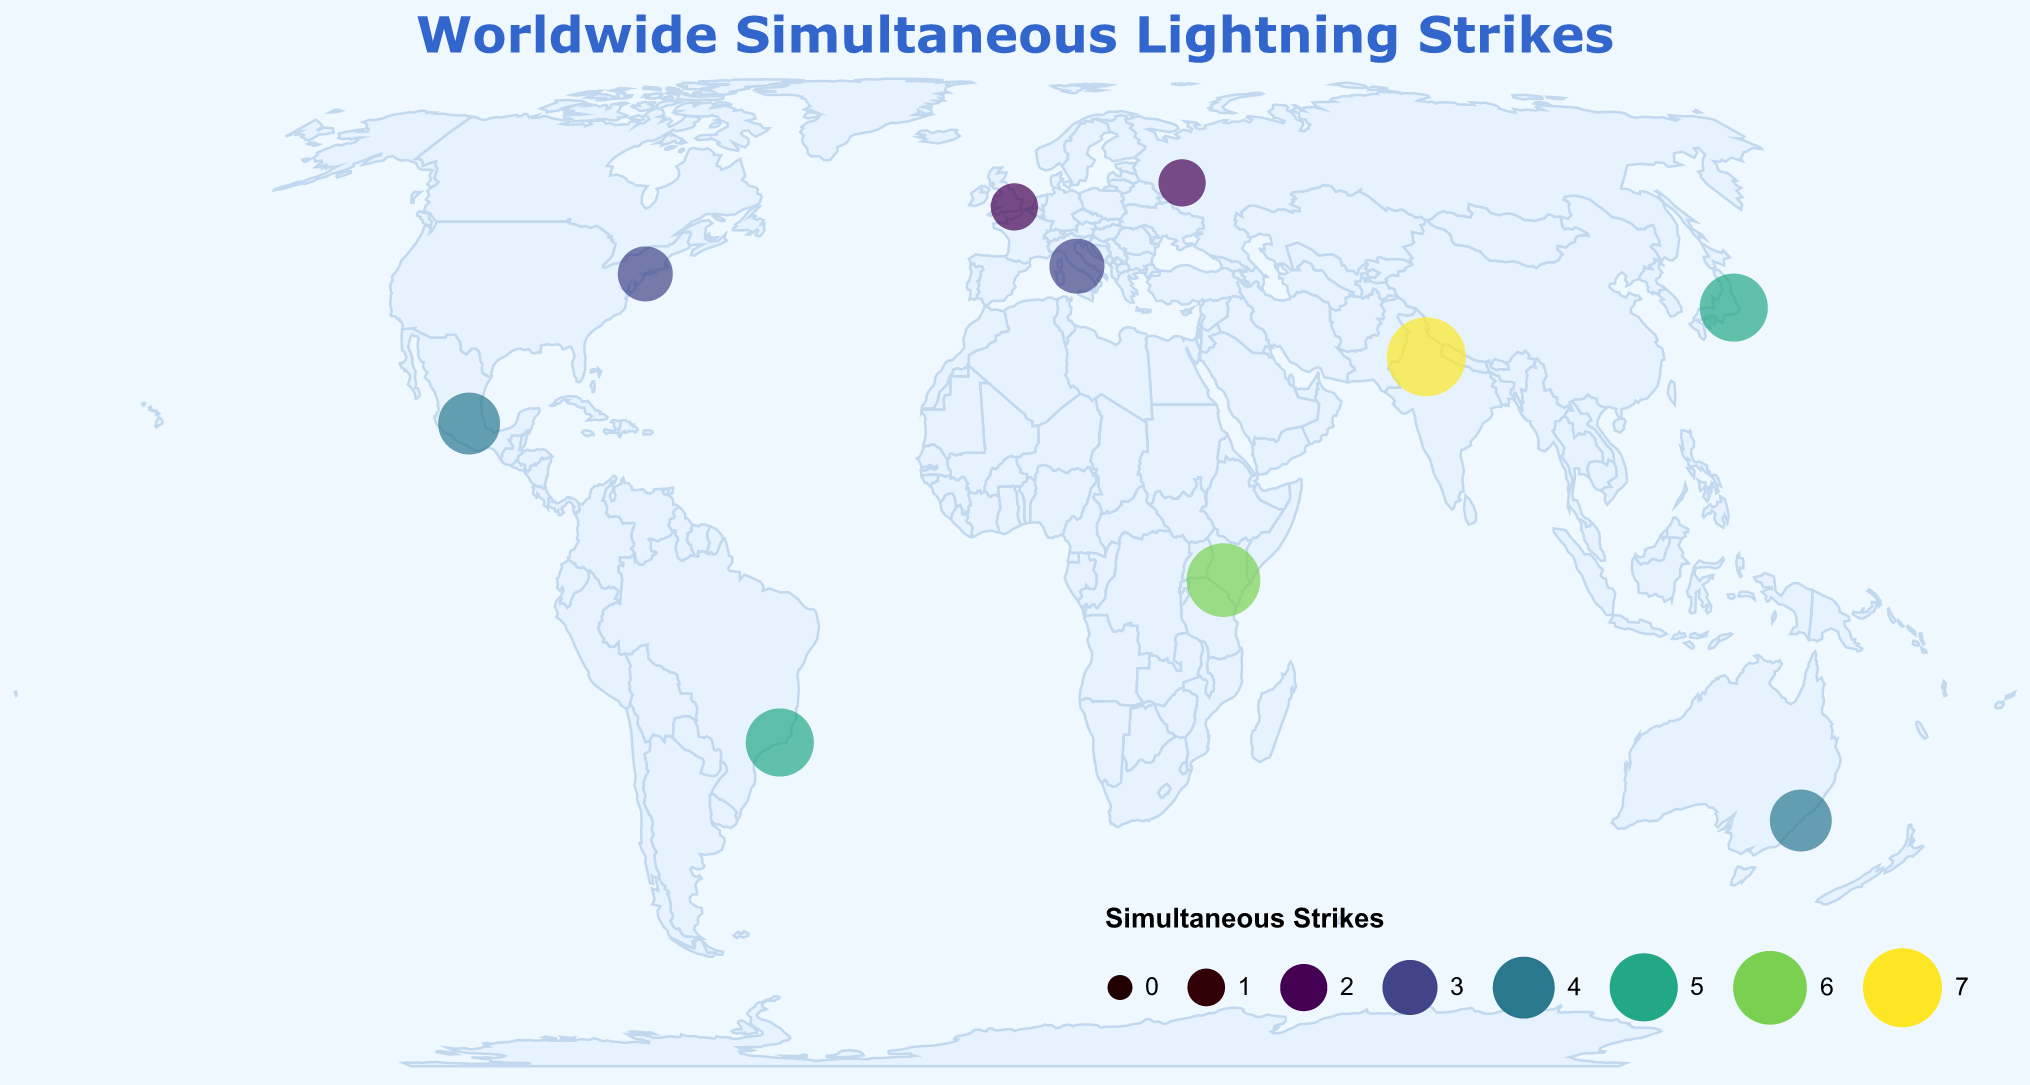Which city experienced the highest number of simultaneous lightning strikes? Find the city with the highest value in the 'Simultaneous Strikes' field, which is New Delhi with 7 strikes.
Answer: New Delhi How many cities had more than 4 simultaneous lightning strikes? Count the cities with 'Simultaneous Strikes' values greater than 4: Tokyo (5), Nairobi (6), New Delhi (7), Rio de Janeiro (5). There are four such cities.
Answer: 4 Which cities had exactly 3 simultaneous lightning strikes? Identify the cities with 'Simultaneous Strikes' equal to 3: New York City and Rome.
Answer: New York City and Rome What is the average number of simultaneous lightning strikes for all listed cities? Sum the number of simultaneous lightning strikes for all cities (3 + 5 + 2 + 4 + 6 + 3 + 4 + 2 + 5 + 7 = 41) and divide by the number of cities (10). The average is 41/10 = 4.1.
Answer: 4.1 Which hemisphere (Northern or Southern) had more total simultaneous lightning strikes? Count total strikes for cities in the Northern Hemisphere (New York City, Tokyo, London, Nairobi, Rome, Mexico City, Moscow, New Delhi: 3+5+2+6+3+4+2+7=32) and the Southern Hemisphere (Sydney, Rio de Janeiro: 4+5=9). The Northern Hemisphere had more.
Answer: Northern Hemisphere What is the geographical spread of cities with 2 simultaneous lightning strikes? Locate cities with 2 strikes: London (UK) and Moscow (Russia) are in Europe.
Answer: Europe What is the difference in the number of simultaneous lightning strikes between Tokyo and Sydney? Subtract the number of strikes in Sydney from that in Tokyo: 5 (Tokyo) - 4 (Sydney) = 1.
Answer: 1 Are there more cities with fewer than 4 or more than 4 simultaneous lightning strikes? Count cities with fewer than 4 strikes (New York City, London, Rome, Moscow: 4) and more than 4 strikes (Tokyo, Sydney, Nairobi, Rio de Janeiro, New Delhi: 5). There are more cities with more than 4 strikes.
Answer: More than 4 Which continent witnessed the highest average number of simultaneous lightning strikes? Calculate the average strikes per city for each continent: North America (3+4=7/2=3.5), Asia (5+7=12/2=6), Europe (2+3=5/2=2.5), Oceania (4/1=4), Africa (6/1=6), South America (5/1=5). Asia and Africa tie with an average of 6 strikes.
Answer: Asia and Africa 